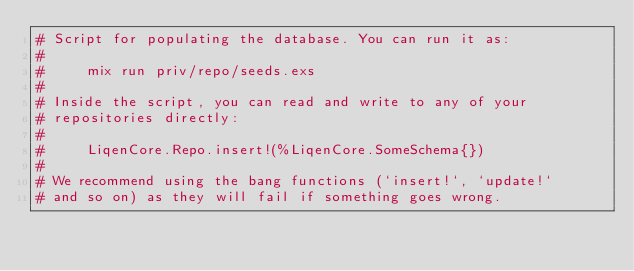<code> <loc_0><loc_0><loc_500><loc_500><_Elixir_># Script for populating the database. You can run it as:
#
#     mix run priv/repo/seeds.exs
#
# Inside the script, you can read and write to any of your
# repositories directly:
#
#     LiqenCore.Repo.insert!(%LiqenCore.SomeSchema{})
#
# We recommend using the bang functions (`insert!`, `update!`
# and so on) as they will fail if something goes wrong.
</code> 